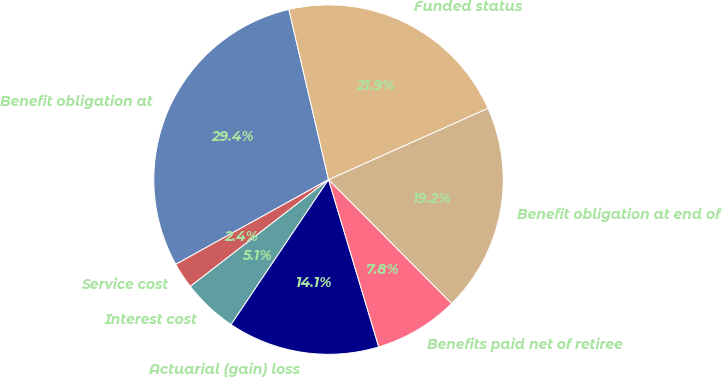<chart> <loc_0><loc_0><loc_500><loc_500><pie_chart><fcel>Benefit obligation at<fcel>Service cost<fcel>Interest cost<fcel>Actuarial (gain) loss<fcel>Benefits paid net of retiree<fcel>Benefit obligation at end of<fcel>Funded status<nl><fcel>29.42%<fcel>2.41%<fcel>5.11%<fcel>14.06%<fcel>7.81%<fcel>19.25%<fcel>21.95%<nl></chart> 